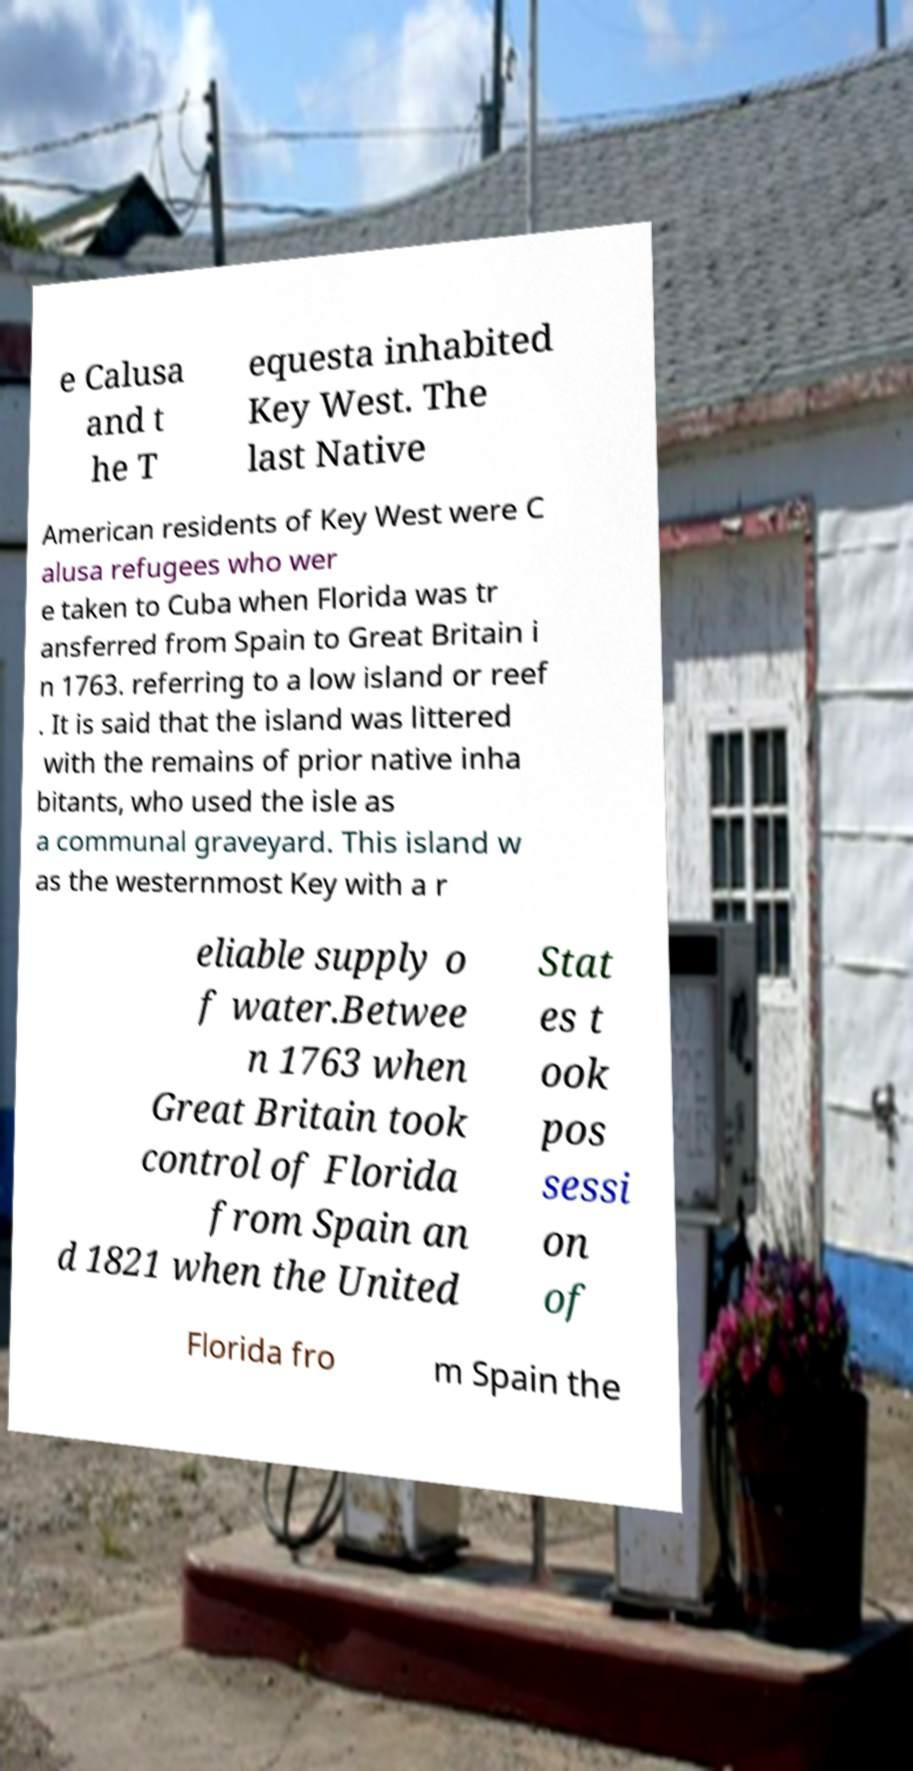There's text embedded in this image that I need extracted. Can you transcribe it verbatim? e Calusa and t he T equesta inhabited Key West. The last Native American residents of Key West were C alusa refugees who wer e taken to Cuba when Florida was tr ansferred from Spain to Great Britain i n 1763. referring to a low island or reef . It is said that the island was littered with the remains of prior native inha bitants, who used the isle as a communal graveyard. This island w as the westernmost Key with a r eliable supply o f water.Betwee n 1763 when Great Britain took control of Florida from Spain an d 1821 when the United Stat es t ook pos sessi on of Florida fro m Spain the 